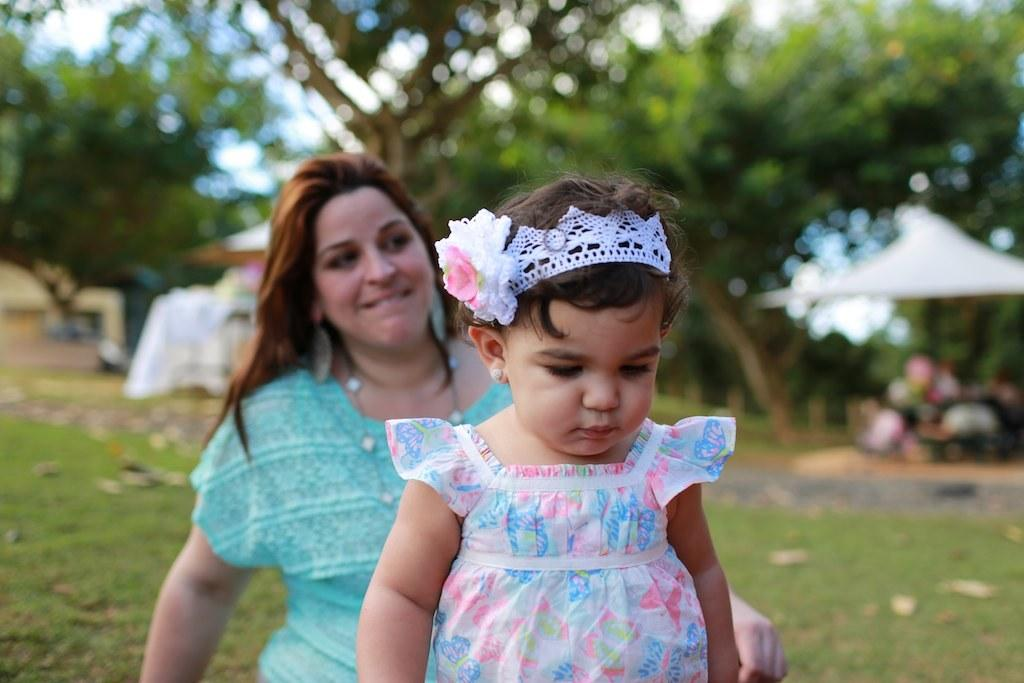What type of vegetation is at the bottom of the image? There is grass at the bottom of the image. Who or what can be seen in the foreground of the image? There are people in the foreground of the image. What can be seen in the background of the image? There are trees in the background of the image. What is visible at the top of the image? The sky is visible at the top of the image. What type of grape is growing on the sidewalk in the image? There is no sidewalk or grape present in the image. Is the gold visible in the image? There is no gold present in the image. 